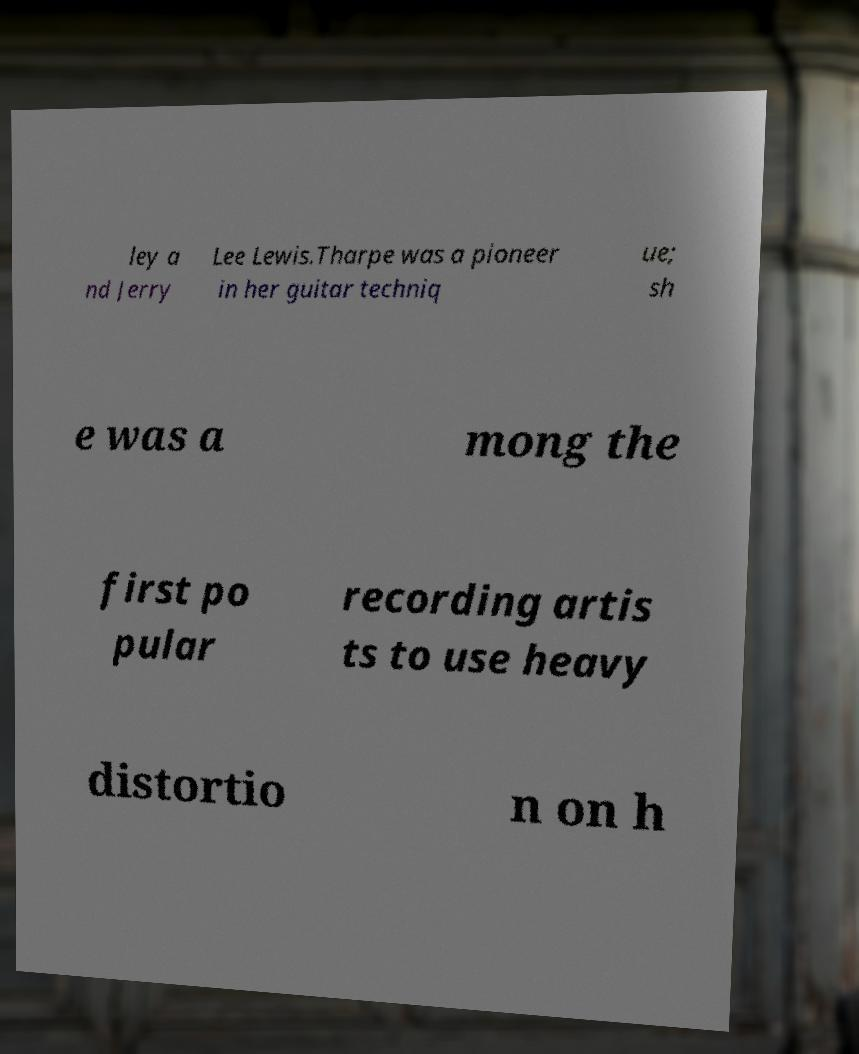I need the written content from this picture converted into text. Can you do that? ley a nd Jerry Lee Lewis.Tharpe was a pioneer in her guitar techniq ue; sh e was a mong the first po pular recording artis ts to use heavy distortio n on h 